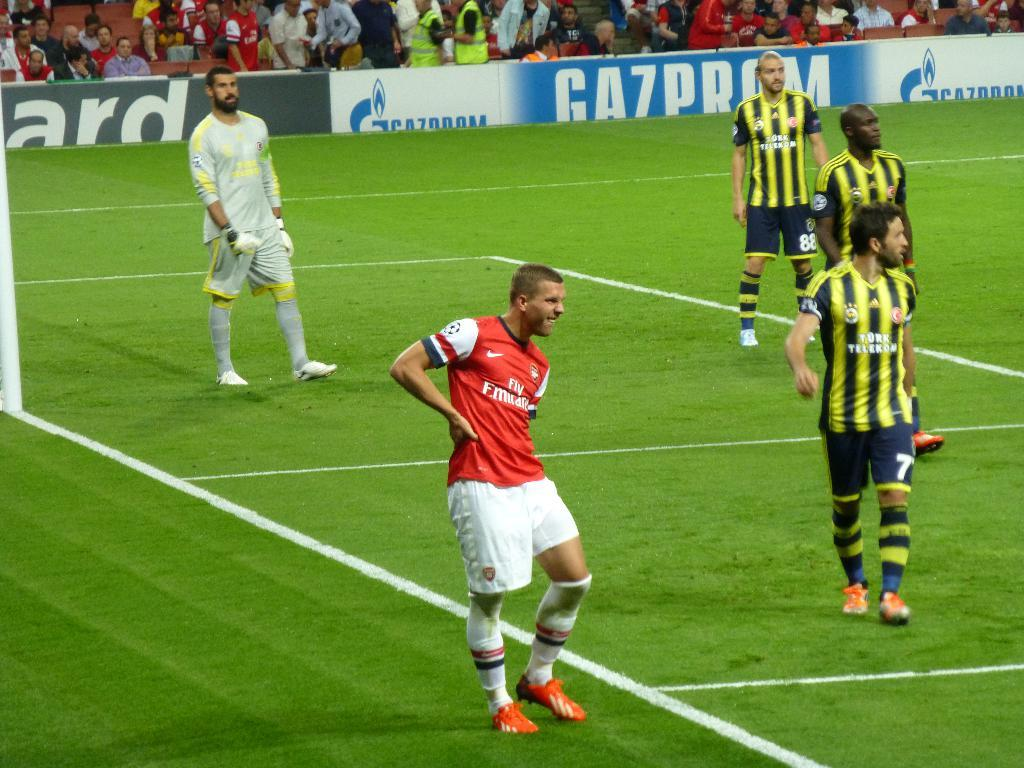<image>
Relay a brief, clear account of the picture shown. A soccer player in a red jersey has the word fly on the front. 